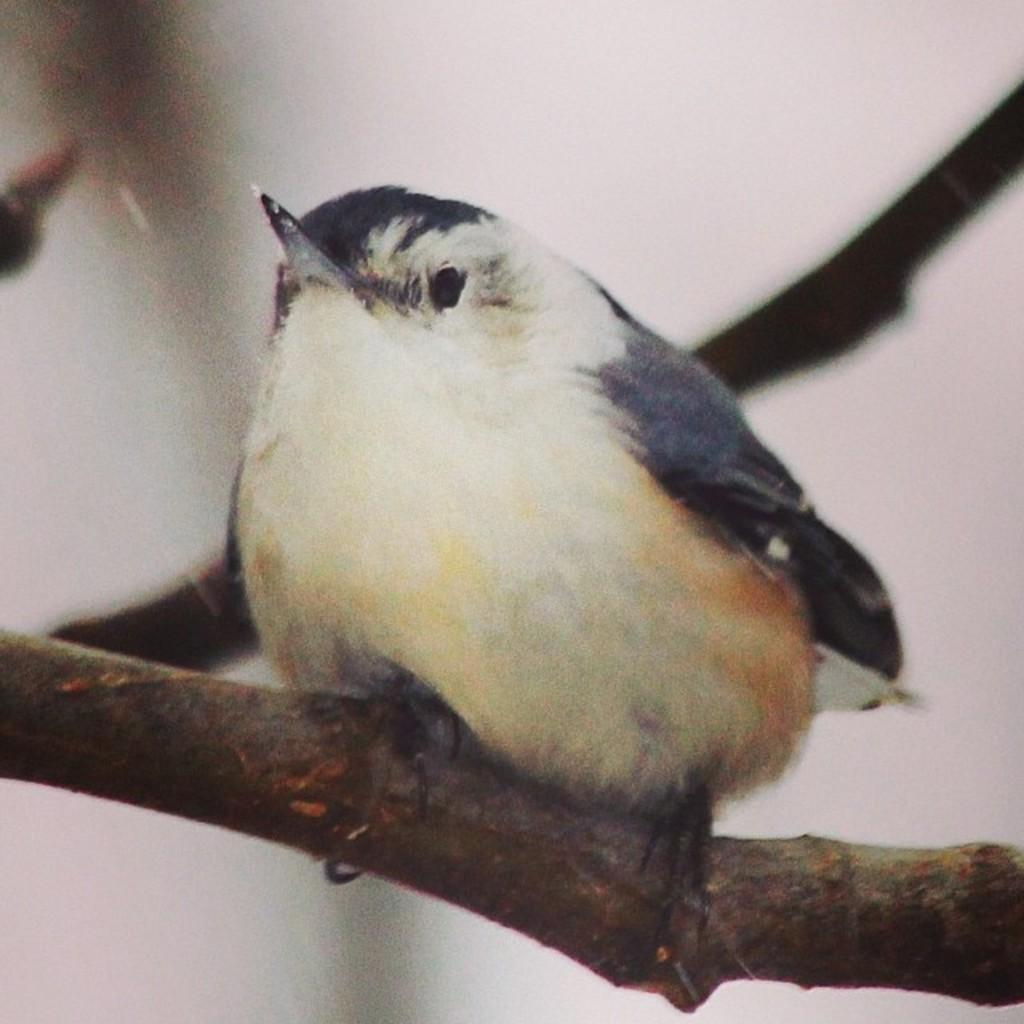What type of animal can be seen in the image? There is a bird in the image. What colors are present on the bird? The bird has white, cream, and black colors. Where is the bird located in the image? The bird is on the branch of a tree. What is the color of the background in the image? The background of the image is white. Can you tell me how many muscles the fish has in the image? There is no fish present in the image, so it is not possible to determine the number of muscles it might have. 